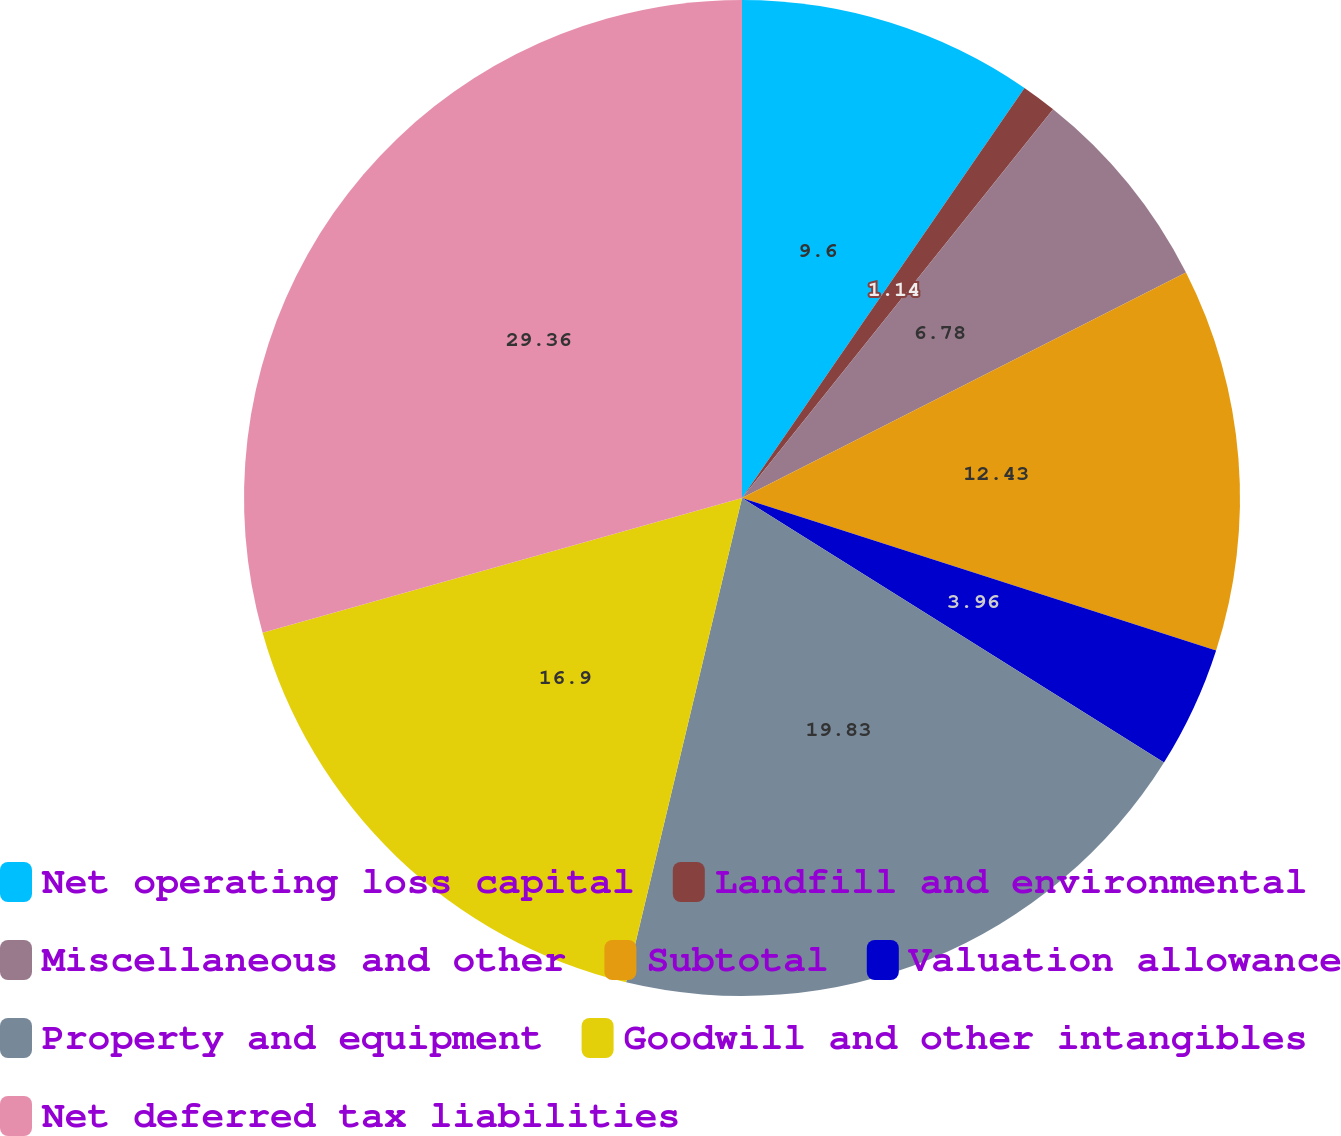Convert chart. <chart><loc_0><loc_0><loc_500><loc_500><pie_chart><fcel>Net operating loss capital<fcel>Landfill and environmental<fcel>Miscellaneous and other<fcel>Subtotal<fcel>Valuation allowance<fcel>Property and equipment<fcel>Goodwill and other intangibles<fcel>Net deferred tax liabilities<nl><fcel>9.6%<fcel>1.14%<fcel>6.78%<fcel>12.43%<fcel>3.96%<fcel>19.83%<fcel>16.9%<fcel>29.36%<nl></chart> 